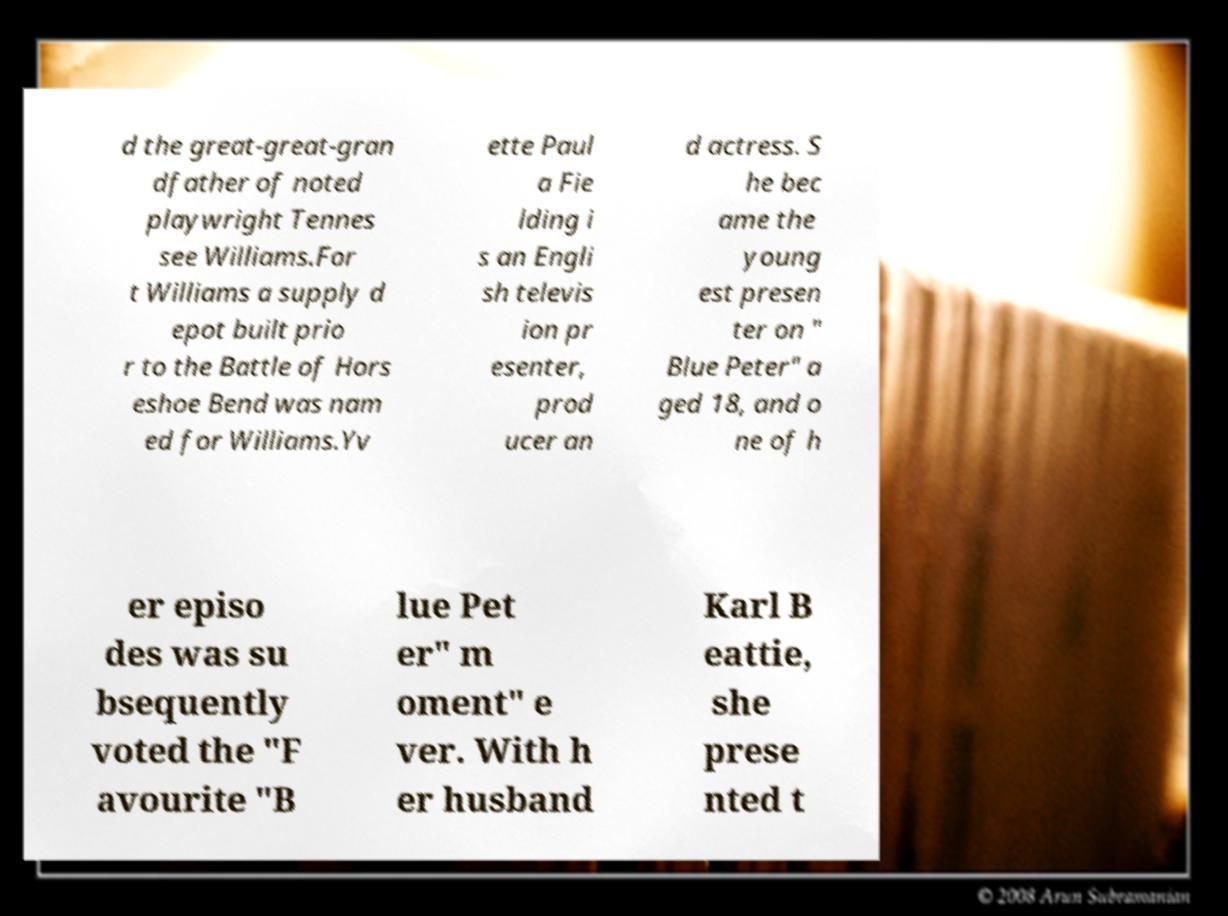There's text embedded in this image that I need extracted. Can you transcribe it verbatim? d the great-great-gran dfather of noted playwright Tennes see Williams.For t Williams a supply d epot built prio r to the Battle of Hors eshoe Bend was nam ed for Williams.Yv ette Paul a Fie lding i s an Engli sh televis ion pr esenter, prod ucer an d actress. S he bec ame the young est presen ter on " Blue Peter" a ged 18, and o ne of h er episo des was su bsequently voted the "F avourite "B lue Pet er" m oment" e ver. With h er husband Karl B eattie, she prese nted t 